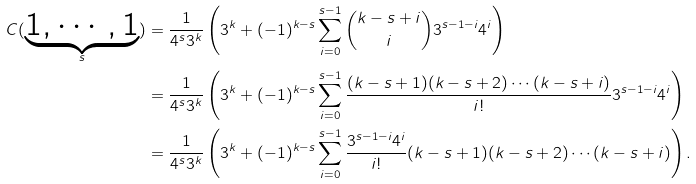<formula> <loc_0><loc_0><loc_500><loc_500>C ( \underbrace { 1 , \cdots , 1 } _ { s } ) & = \frac { 1 } { 4 ^ { s } 3 ^ { k } } \left ( 3 ^ { k } + ( - 1 ) ^ { k - s } \sum _ { i = 0 } ^ { s - 1 } \binom { k - s + i } { i } 3 ^ { s - 1 - i } 4 ^ { i } \right ) \\ & = \frac { 1 } { 4 ^ { s } 3 ^ { k } } \left ( 3 ^ { k } + ( - 1 ) ^ { k - s } \sum _ { i = 0 } ^ { s - 1 } \frac { ( k - s + 1 ) ( k - s + 2 ) \cdots ( k - s + i ) } { i ! } 3 ^ { s - 1 - i } 4 ^ { i } \right ) \\ & = \frac { 1 } { 4 ^ { s } 3 ^ { k } } \left ( 3 ^ { k } + ( - 1 ) ^ { k - s } \sum _ { i = 0 } ^ { s - 1 } \frac { 3 ^ { s - 1 - i } 4 ^ { i } } { i ! } ( k - s + 1 ) ( k - s + 2 ) \cdots ( k - s + i ) \right ) .</formula> 